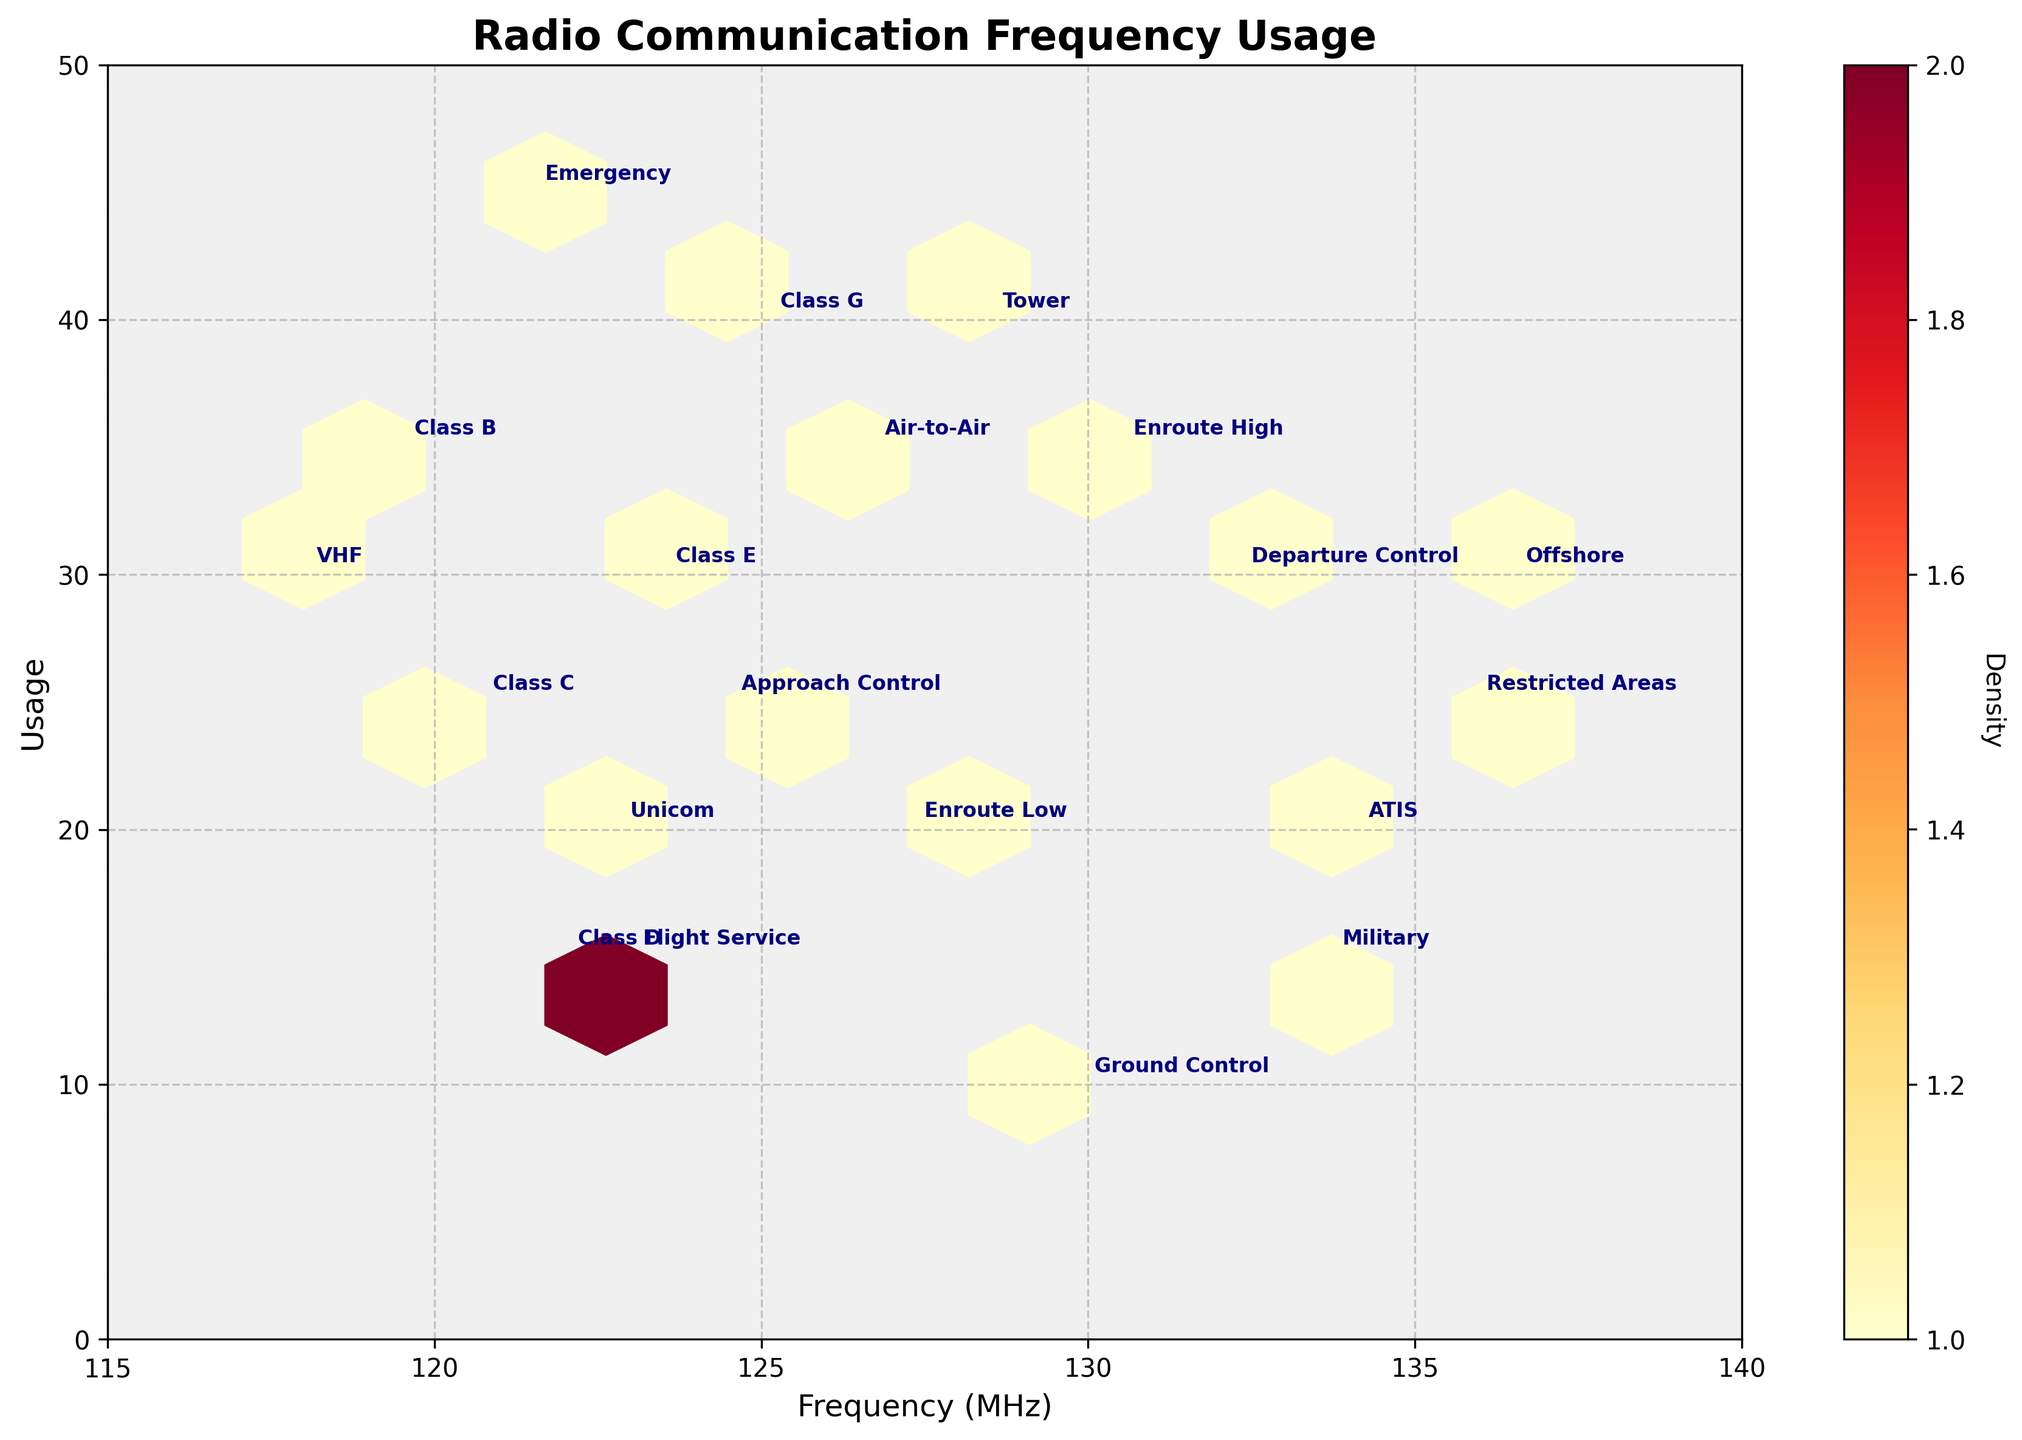What is the range of the x-axis in the plot? The x-axis range is defined by the limits set from 115 to 140 MHz.
Answer: 115 to 140 MHz How many unique frequency usage categories are there in the plot? Each unique category corresponds to a unique 'frequency' value annotated on the plot. There are 20 unique categories.
Answer: 20 Which frequency usage category is placed at the highest frequency value? The highest frequency value on the x-axis is 136.5 MHz, and the corresponding annotated category is Offshore.
Answer: Offshore What is the densest hexbin region in the plot? The densest region will be indicated by the hexbin with the highest color intensity (YlOrRd color map), typically towards the yellow to red regions. By examining the plot, this region needs to be identified.
Answer: The highest density region location (user observation) Compare the frequency values of the categories 'Air-to-Air' and 'Tower'. Which one is higher? The frequency value for 'Air-to-Air' is 126.7 MHz, whereas for 'Tower' it is 128.5 MHz. Hence, 'Tower' has a higher frequency.
Answer: Tower What is the usage value for the 'Class G' frequency category? The usage value for 'Class G' is annotated and placed on the y-axis at 40.
Answer: 40 Which categories fall under the frequency range of 118 MHz to 124 MHz? By examining the x-axis and identifying the categories within this range, the categories are 'VHF' (118.0 MHz), 'Emergency' (121.5 MHz), 'Unicom' (122.8 MHz), 'Flight Service' (123.0 MHz).
Answer: VHF, Emergency, Unicom, Flight Service Is there any category that has the same usage value as 'Air-to-Air'? If so, name it. 'Air-to-Air' has a usage value of 35. By checking other categories with the same usage value, 'Class B' (119.5 MHz) and 'Enroute High' (130.5 MHz) match the same usage value of 35.
Answer: Class B, Enroute High What is the difference in usage between 'Approach Control' and 'Ground Control'? 'Approach Control' has a usage value of 25 while 'Ground Control' has a usage value of 10. The difference is 25 - 10.
Answer: 15 What is the frequency and usage value for the category 'Departure Control'? The annotation on the plot gives these values directly: Frequency is 132.3 MHz and usage is 30.
Answer: 132.3 MHz, 30 